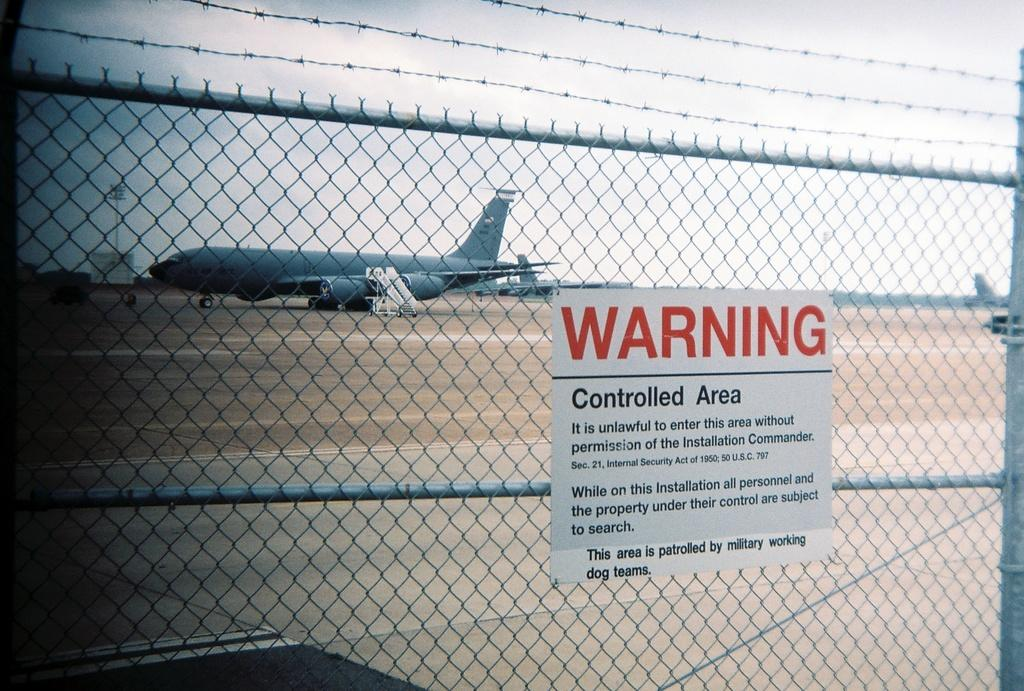<image>
Provide a brief description of the given image. behind the Warning sign is a fenced in area with a plane in it 